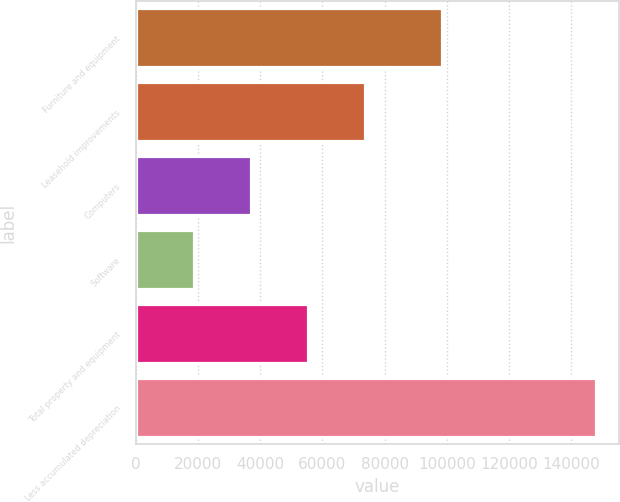Convert chart. <chart><loc_0><loc_0><loc_500><loc_500><bar_chart><fcel>Furniture and equipment<fcel>Leasehold improvements<fcel>Computers<fcel>Software<fcel>Total property and equipment<fcel>Less accumulated depreciation<nl><fcel>98387<fcel>73785.8<fcel>37050.6<fcel>18683<fcel>55418.2<fcel>147826<nl></chart> 